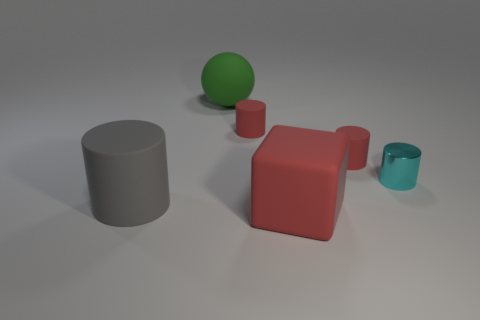Subtract all large gray cylinders. How many cylinders are left? 3 Subtract all red cylinders. How many cylinders are left? 2 Subtract 1 balls. How many balls are left? 0 Add 2 cyan objects. How many objects exist? 8 Subtract all cyan cylinders. How many yellow balls are left? 0 Subtract all gray matte things. Subtract all small metallic objects. How many objects are left? 4 Add 5 large green objects. How many large green objects are left? 6 Add 6 large objects. How many large objects exist? 9 Subtract 0 yellow spheres. How many objects are left? 6 Subtract all spheres. How many objects are left? 5 